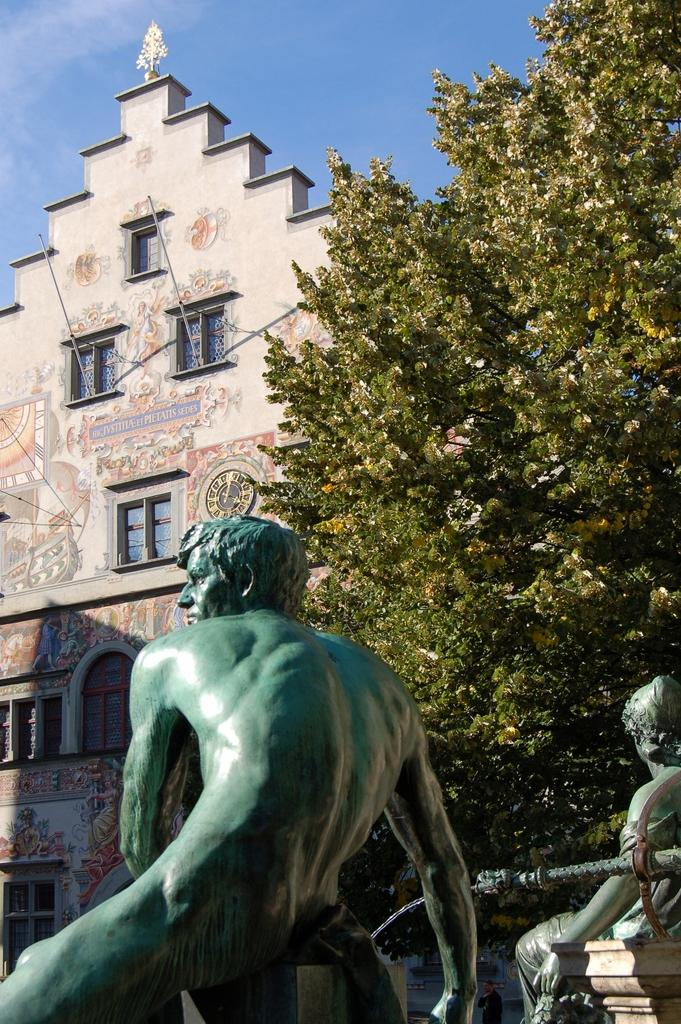What can be found in the right corner of the image? There are two statues in the right corner of the image. What is visible in the background of the image? There is a tree and a building in the background of the image. What type of guitar is being played by the statues in the image? There are no guitars present in the image; the main subjects are the two statues. What act are the statues performing in the image? The statues are not performing any act in the image; they are stationary. 